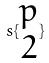Convert formula to latex. <formula><loc_0><loc_0><loc_500><loc_500>s \{ \begin{matrix} p \\ 2 \end{matrix} \}</formula> 